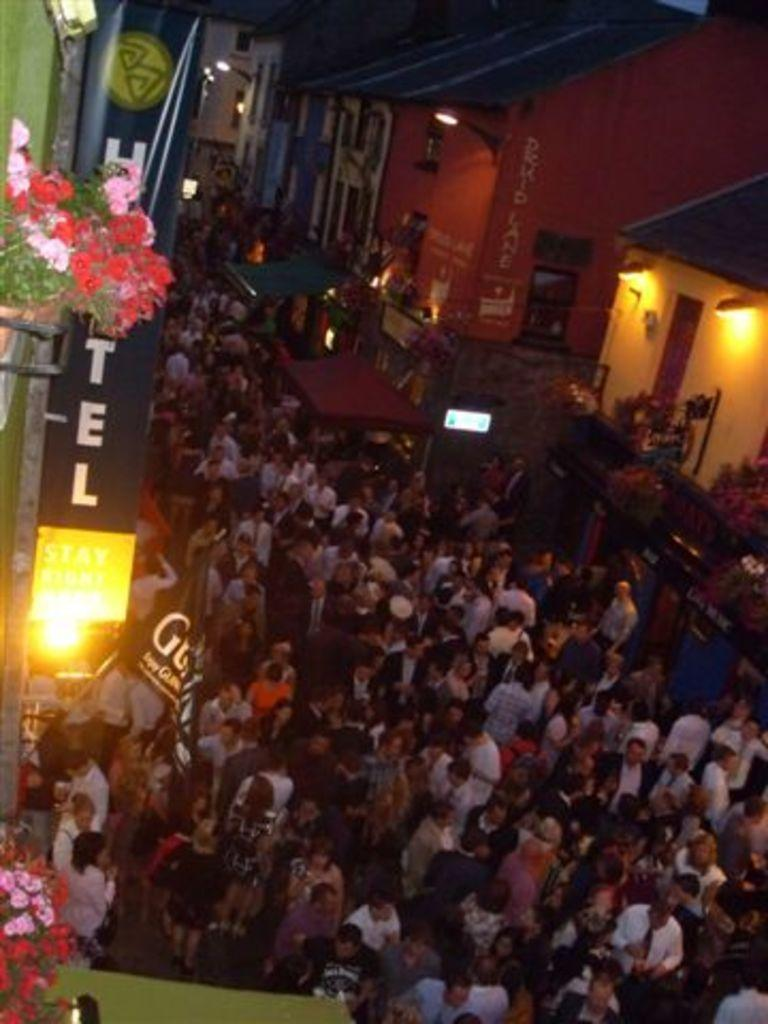What can be seen in the image involving human presence? There are people standing in the image. What type of structures are visible in the image? There are buildings in the image. What is the source of illumination in the image? There is light visible in the image. What type of vegetation is present in the image? There is a plant in the image. What type of brush is being used to solve arithmetic problems in the image? There is no brush or arithmetic problems present in the image. How many balls are visible in the image? There are no balls visible in the image. 